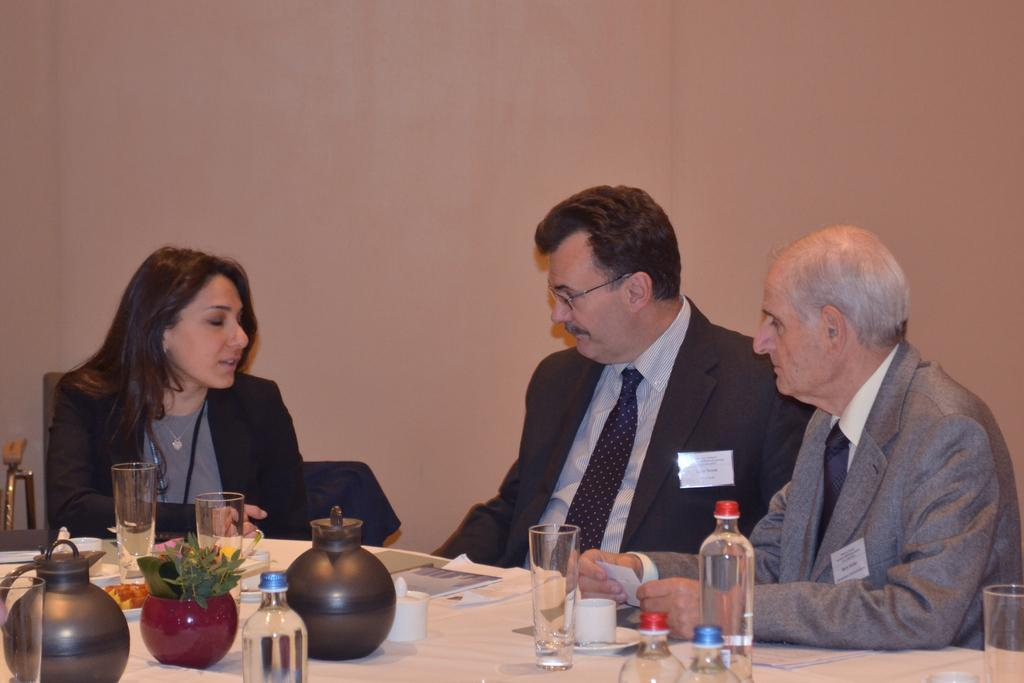How many people are present in the image? There are three people in the image: one woman and two men. What are they doing in the image? They are sitting on chairs around a table. What can be seen on the table? There are water bottles, jars, and bowls on the table. What direction is the feast moving in the image? There is no feast present in the image, so it cannot be moving in any direction. 